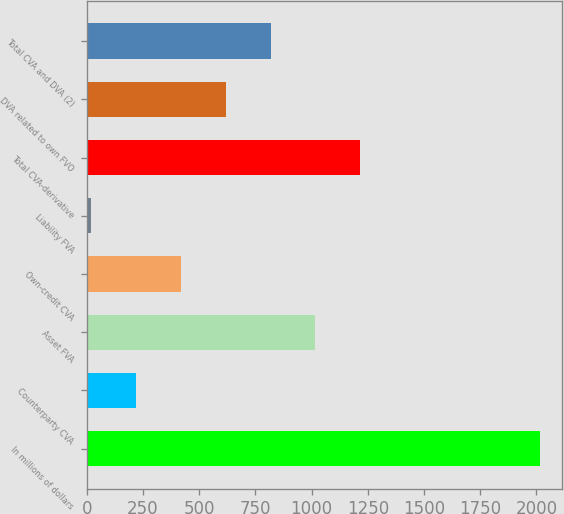Convert chart to OTSL. <chart><loc_0><loc_0><loc_500><loc_500><bar_chart><fcel>In millions of dollars<fcel>Counterparty CVA<fcel>Asset FVA<fcel>Own-credit CVA<fcel>Liability FVA<fcel>Total CVA-derivative<fcel>DVA related to own FVO<fcel>Total CVA and DVA (2)<nl><fcel>2014<fcel>218.5<fcel>1016.5<fcel>418<fcel>19<fcel>1216<fcel>617.5<fcel>817<nl></chart> 